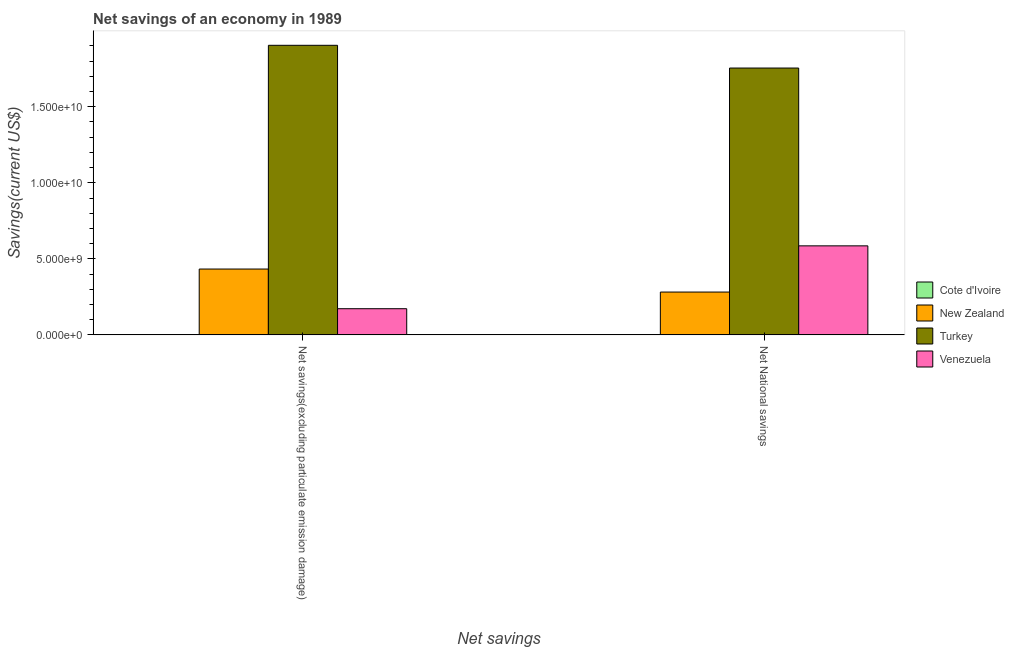Are the number of bars per tick equal to the number of legend labels?
Your response must be concise. No. How many bars are there on the 2nd tick from the left?
Give a very brief answer. 3. How many bars are there on the 1st tick from the right?
Your answer should be very brief. 3. What is the label of the 1st group of bars from the left?
Your response must be concise. Net savings(excluding particulate emission damage). What is the net national savings in Cote d'Ivoire?
Give a very brief answer. 0. Across all countries, what is the maximum net national savings?
Make the answer very short. 1.75e+1. In which country was the net savings(excluding particulate emission damage) maximum?
Offer a terse response. Turkey. What is the total net national savings in the graph?
Offer a terse response. 2.62e+1. What is the difference between the net savings(excluding particulate emission damage) in Turkey and that in New Zealand?
Keep it short and to the point. 1.47e+1. What is the difference between the net savings(excluding particulate emission damage) in Venezuela and the net national savings in New Zealand?
Your answer should be compact. -1.10e+09. What is the average net national savings per country?
Make the answer very short. 6.55e+09. What is the difference between the net savings(excluding particulate emission damage) and net national savings in Turkey?
Your answer should be compact. 1.49e+09. In how many countries, is the net savings(excluding particulate emission damage) greater than 8000000000 US$?
Your answer should be very brief. 1. What is the ratio of the net national savings in Venezuela to that in New Zealand?
Make the answer very short. 2.08. Is the net national savings in Turkey less than that in New Zealand?
Ensure brevity in your answer.  No. In how many countries, is the net savings(excluding particulate emission damage) greater than the average net savings(excluding particulate emission damage) taken over all countries?
Your answer should be very brief. 1. How many bars are there?
Provide a succinct answer. 6. What is the difference between two consecutive major ticks on the Y-axis?
Your response must be concise. 5.00e+09. Are the values on the major ticks of Y-axis written in scientific E-notation?
Ensure brevity in your answer.  Yes. Where does the legend appear in the graph?
Offer a terse response. Center right. How are the legend labels stacked?
Your response must be concise. Vertical. What is the title of the graph?
Offer a terse response. Net savings of an economy in 1989. Does "Hong Kong" appear as one of the legend labels in the graph?
Offer a very short reply. No. What is the label or title of the X-axis?
Give a very brief answer. Net savings. What is the label or title of the Y-axis?
Offer a very short reply. Savings(current US$). What is the Savings(current US$) of New Zealand in Net savings(excluding particulate emission damage)?
Offer a very short reply. 4.33e+09. What is the Savings(current US$) of Turkey in Net savings(excluding particulate emission damage)?
Keep it short and to the point. 1.90e+1. What is the Savings(current US$) of Venezuela in Net savings(excluding particulate emission damage)?
Offer a very short reply. 1.72e+09. What is the Savings(current US$) of New Zealand in Net National savings?
Your answer should be compact. 2.82e+09. What is the Savings(current US$) in Turkey in Net National savings?
Make the answer very short. 1.75e+1. What is the Savings(current US$) in Venezuela in Net National savings?
Provide a succinct answer. 5.85e+09. Across all Net savings, what is the maximum Savings(current US$) in New Zealand?
Keep it short and to the point. 4.33e+09. Across all Net savings, what is the maximum Savings(current US$) of Turkey?
Provide a succinct answer. 1.90e+1. Across all Net savings, what is the maximum Savings(current US$) in Venezuela?
Provide a short and direct response. 5.85e+09. Across all Net savings, what is the minimum Savings(current US$) in New Zealand?
Provide a short and direct response. 2.82e+09. Across all Net savings, what is the minimum Savings(current US$) of Turkey?
Offer a terse response. 1.75e+1. Across all Net savings, what is the minimum Savings(current US$) of Venezuela?
Your answer should be compact. 1.72e+09. What is the total Savings(current US$) of New Zealand in the graph?
Your response must be concise. 7.15e+09. What is the total Savings(current US$) of Turkey in the graph?
Your response must be concise. 3.66e+1. What is the total Savings(current US$) of Venezuela in the graph?
Your answer should be very brief. 7.58e+09. What is the difference between the Savings(current US$) of New Zealand in Net savings(excluding particulate emission damage) and that in Net National savings?
Provide a short and direct response. 1.51e+09. What is the difference between the Savings(current US$) in Turkey in Net savings(excluding particulate emission damage) and that in Net National savings?
Your answer should be compact. 1.49e+09. What is the difference between the Savings(current US$) of Venezuela in Net savings(excluding particulate emission damage) and that in Net National savings?
Give a very brief answer. -4.13e+09. What is the difference between the Savings(current US$) of New Zealand in Net savings(excluding particulate emission damage) and the Savings(current US$) of Turkey in Net National savings?
Your answer should be compact. -1.32e+1. What is the difference between the Savings(current US$) in New Zealand in Net savings(excluding particulate emission damage) and the Savings(current US$) in Venezuela in Net National savings?
Offer a terse response. -1.52e+09. What is the difference between the Savings(current US$) in Turkey in Net savings(excluding particulate emission damage) and the Savings(current US$) in Venezuela in Net National savings?
Offer a very short reply. 1.32e+1. What is the average Savings(current US$) of Cote d'Ivoire per Net savings?
Your answer should be very brief. 0. What is the average Savings(current US$) in New Zealand per Net savings?
Your response must be concise. 3.57e+09. What is the average Savings(current US$) of Turkey per Net savings?
Make the answer very short. 1.83e+1. What is the average Savings(current US$) in Venezuela per Net savings?
Ensure brevity in your answer.  3.79e+09. What is the difference between the Savings(current US$) of New Zealand and Savings(current US$) of Turkey in Net savings(excluding particulate emission damage)?
Your answer should be compact. -1.47e+1. What is the difference between the Savings(current US$) in New Zealand and Savings(current US$) in Venezuela in Net savings(excluding particulate emission damage)?
Offer a very short reply. 2.61e+09. What is the difference between the Savings(current US$) of Turkey and Savings(current US$) of Venezuela in Net savings(excluding particulate emission damage)?
Keep it short and to the point. 1.73e+1. What is the difference between the Savings(current US$) in New Zealand and Savings(current US$) in Turkey in Net National savings?
Your answer should be very brief. -1.47e+1. What is the difference between the Savings(current US$) of New Zealand and Savings(current US$) of Venezuela in Net National savings?
Offer a very short reply. -3.04e+09. What is the difference between the Savings(current US$) of Turkey and Savings(current US$) of Venezuela in Net National savings?
Keep it short and to the point. 1.17e+1. What is the ratio of the Savings(current US$) in New Zealand in Net savings(excluding particulate emission damage) to that in Net National savings?
Offer a terse response. 1.54. What is the ratio of the Savings(current US$) of Turkey in Net savings(excluding particulate emission damage) to that in Net National savings?
Make the answer very short. 1.09. What is the ratio of the Savings(current US$) of Venezuela in Net savings(excluding particulate emission damage) to that in Net National savings?
Offer a very short reply. 0.29. What is the difference between the highest and the second highest Savings(current US$) in New Zealand?
Give a very brief answer. 1.51e+09. What is the difference between the highest and the second highest Savings(current US$) in Turkey?
Keep it short and to the point. 1.49e+09. What is the difference between the highest and the second highest Savings(current US$) of Venezuela?
Provide a succinct answer. 4.13e+09. What is the difference between the highest and the lowest Savings(current US$) of New Zealand?
Provide a short and direct response. 1.51e+09. What is the difference between the highest and the lowest Savings(current US$) in Turkey?
Make the answer very short. 1.49e+09. What is the difference between the highest and the lowest Savings(current US$) of Venezuela?
Make the answer very short. 4.13e+09. 